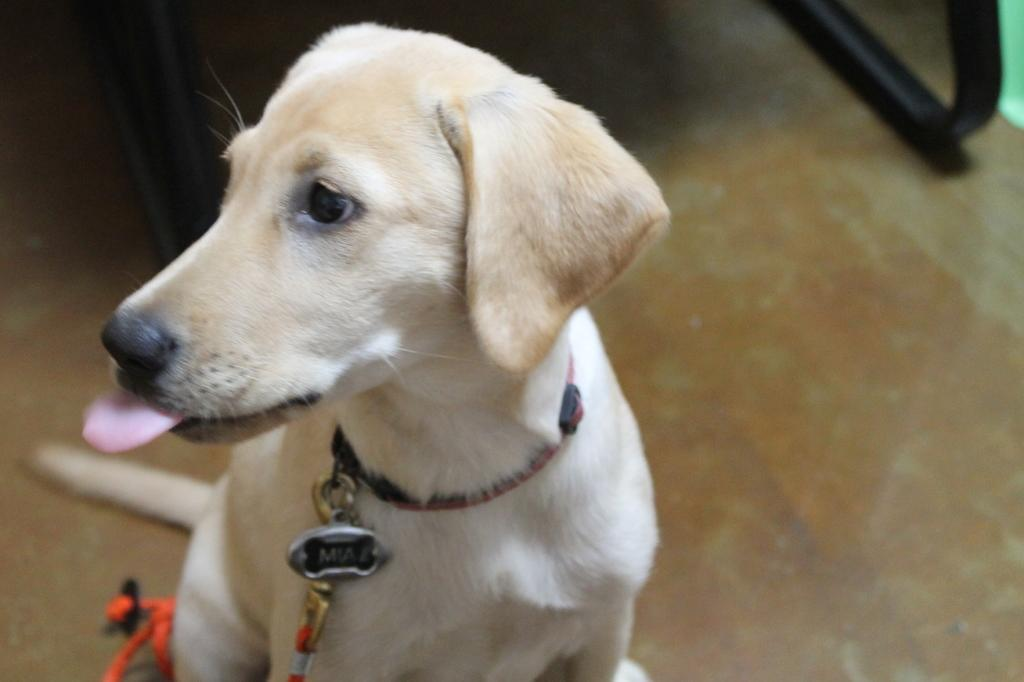What is the main subject of the image? There is a dog in the center of the image. What is attached to the dog? The dog has a chain. What can be seen in the background of the image? There is a stand in the background of the image. What is on the floor in the image? There is an object on the floor in the image. What type of pencil can be seen in the dog's mouth in the image? There is no pencil present in the image, and the dog does not have a pencil in its mouth. 